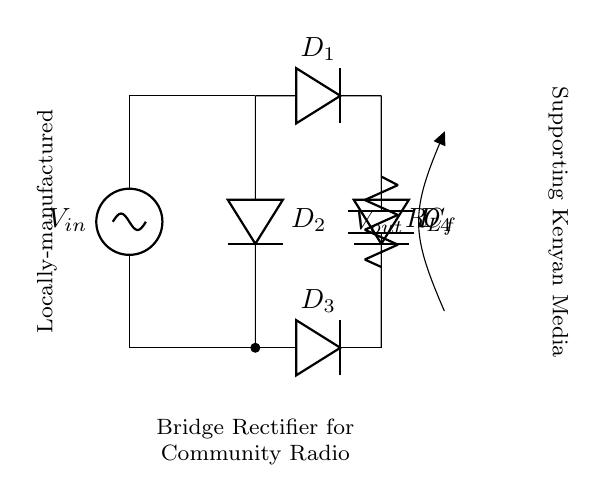What is the input voltage source? The input voltage source is marked as V_in at the top left corner of the circuit diagram.
Answer: V_in How many diodes are used in the bridge rectifier? The bridge rectifier consists of four diodes labeled D1, D2, D3, and D4 clearly shown in the circuit.
Answer: 4 What type of load is connected to the output? The load is represented by the resistor labeled R_L at the bottom right of the diagram, indicating it is a resistive load.
Answer: Resistor What is the function of the capacitor in the circuit? The capacitor marked as C_f is connected across the output and serves to smooth out the voltage, which is a common function in rectifiers to minimize fluctuations.
Answer: Smoothing What is the output voltage component labeled as? The output voltage is labeled V_out, shown at the right side of the diagram, indicating the voltage across the load and capacitor.
Answer: V_out What is the purpose of a bridge rectifier in this configuration? A bridge rectifier converts alternating current from the input into direct current for the radio transmitter, providing the necessary power for operation.
Answer: Conversion What is the significance of locally-manufactured components in this context? Locally-manufactured components promote self-sufficiency and support community-based media by ensuring accessibility and durability of the radio transmitters.
Answer: Support local industry 